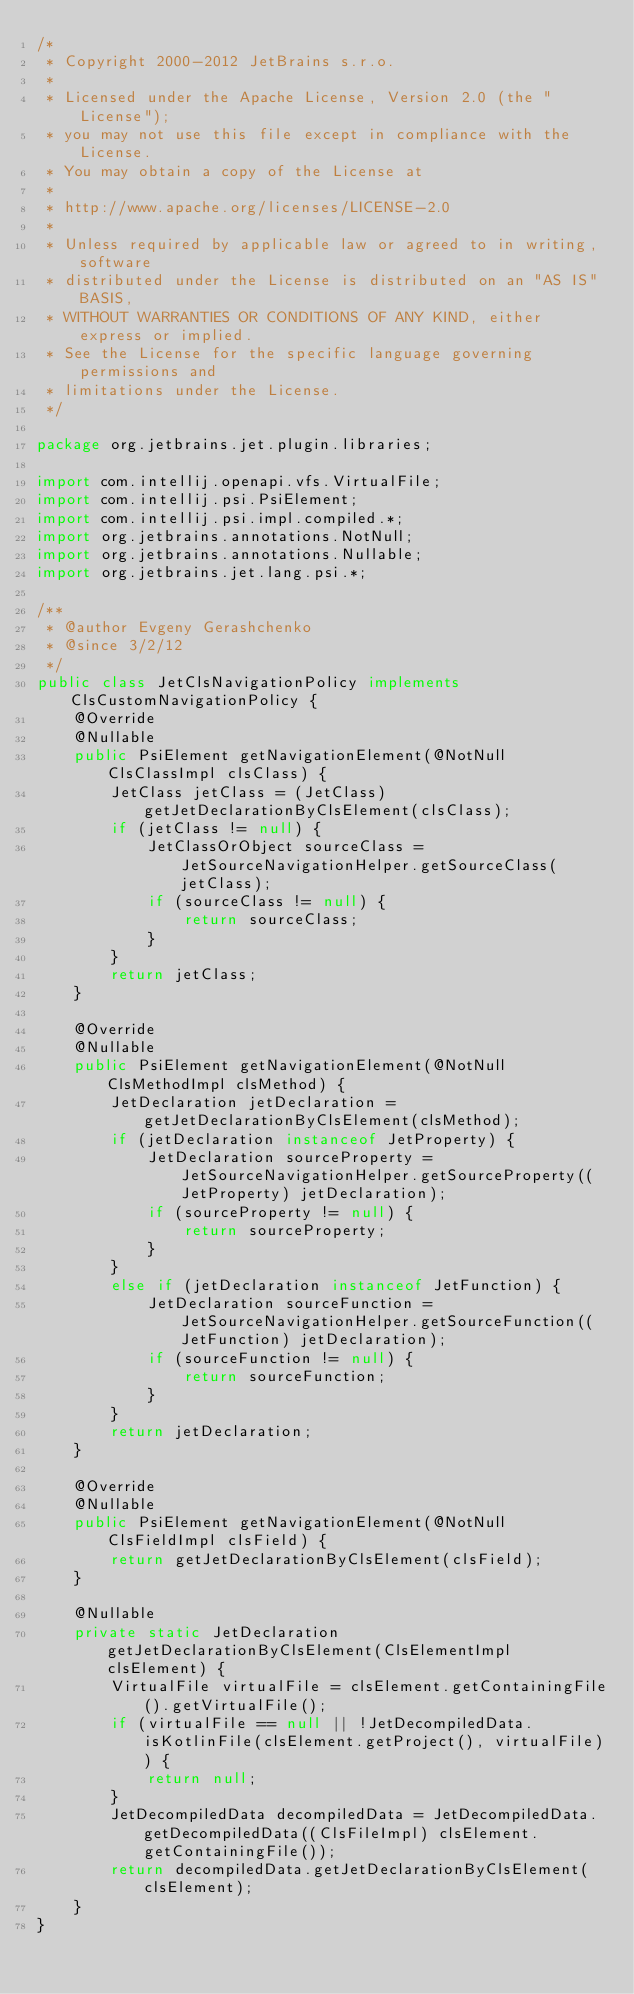<code> <loc_0><loc_0><loc_500><loc_500><_Java_>/*
 * Copyright 2000-2012 JetBrains s.r.o.
 *
 * Licensed under the Apache License, Version 2.0 (the "License");
 * you may not use this file except in compliance with the License.
 * You may obtain a copy of the License at
 *
 * http://www.apache.org/licenses/LICENSE-2.0
 *
 * Unless required by applicable law or agreed to in writing, software
 * distributed under the License is distributed on an "AS IS" BASIS,
 * WITHOUT WARRANTIES OR CONDITIONS OF ANY KIND, either express or implied.
 * See the License for the specific language governing permissions and
 * limitations under the License.
 */

package org.jetbrains.jet.plugin.libraries;

import com.intellij.openapi.vfs.VirtualFile;
import com.intellij.psi.PsiElement;
import com.intellij.psi.impl.compiled.*;
import org.jetbrains.annotations.NotNull;
import org.jetbrains.annotations.Nullable;
import org.jetbrains.jet.lang.psi.*;

/**
 * @author Evgeny Gerashchenko
 * @since 3/2/12
 */
public class JetClsNavigationPolicy implements ClsCustomNavigationPolicy {
    @Override
    @Nullable
    public PsiElement getNavigationElement(@NotNull ClsClassImpl clsClass) {
        JetClass jetClass = (JetClass) getJetDeclarationByClsElement(clsClass);
        if (jetClass != null) {
            JetClassOrObject sourceClass = JetSourceNavigationHelper.getSourceClass(jetClass);
            if (sourceClass != null) {
                return sourceClass;
            }
        }
        return jetClass;
    }

    @Override
    @Nullable
    public PsiElement getNavigationElement(@NotNull ClsMethodImpl clsMethod) {
        JetDeclaration jetDeclaration = getJetDeclarationByClsElement(clsMethod);
        if (jetDeclaration instanceof JetProperty) {
            JetDeclaration sourceProperty = JetSourceNavigationHelper.getSourceProperty((JetProperty) jetDeclaration);
            if (sourceProperty != null) {
                return sourceProperty;
            }
        }
        else if (jetDeclaration instanceof JetFunction) {
            JetDeclaration sourceFunction = JetSourceNavigationHelper.getSourceFunction((JetFunction) jetDeclaration);
            if (sourceFunction != null) {
                return sourceFunction;
            }
        }
        return jetDeclaration;
    }

    @Override
    @Nullable
    public PsiElement getNavigationElement(@NotNull ClsFieldImpl clsField) {
        return getJetDeclarationByClsElement(clsField);
    }

    @Nullable
    private static JetDeclaration getJetDeclarationByClsElement(ClsElementImpl clsElement) {
        VirtualFile virtualFile = clsElement.getContainingFile().getVirtualFile();
        if (virtualFile == null || !JetDecompiledData.isKotlinFile(clsElement.getProject(), virtualFile)) {
            return null;
        }
        JetDecompiledData decompiledData = JetDecompiledData.getDecompiledData((ClsFileImpl) clsElement.getContainingFile());
        return decompiledData.getJetDeclarationByClsElement(clsElement);
    }
}
</code> 